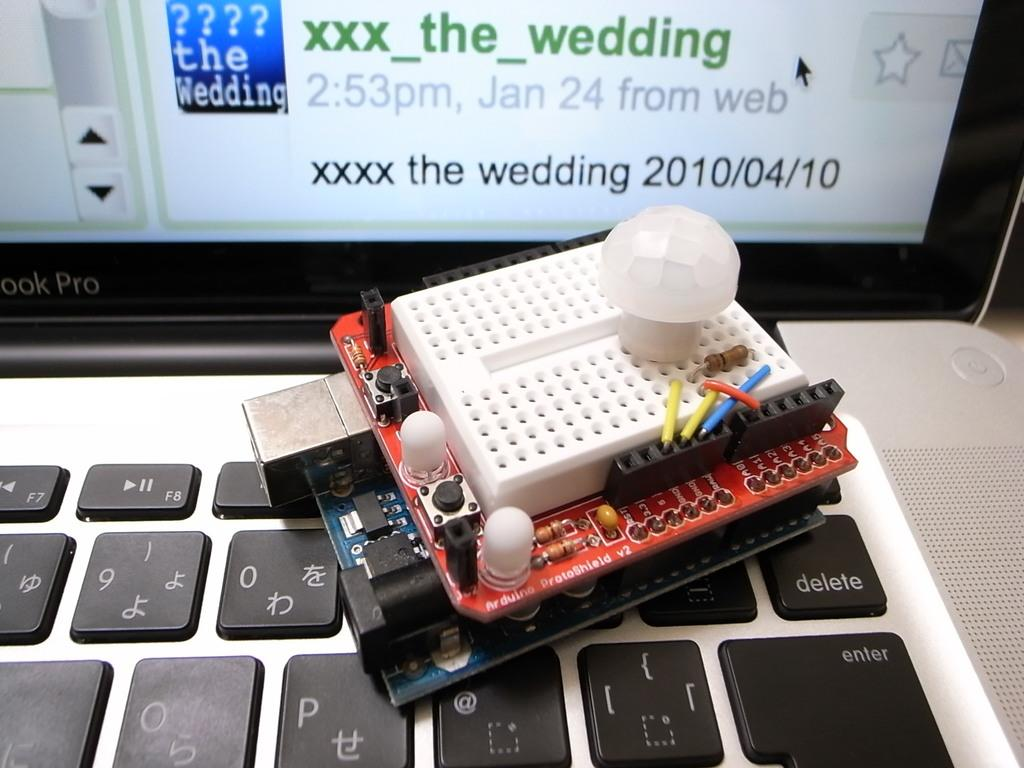<image>
Create a compact narrative representing the image presented. A wedding date in 2010 can be seen on a screen behind a keyboard. 